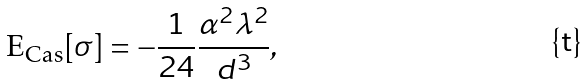Convert formula to latex. <formula><loc_0><loc_0><loc_500><loc_500>\text {E} _ { \text {Cas} } [ \sigma ] = - \frac { 1 } { 2 4 } \frac { \alpha ^ { 2 } \lambda ^ { 2 } } { d ^ { 3 } } ,</formula> 